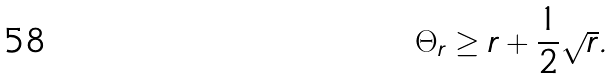<formula> <loc_0><loc_0><loc_500><loc_500>\Theta _ { r } \geq r + \frac { 1 } { 2 } \sqrt { r } .</formula> 